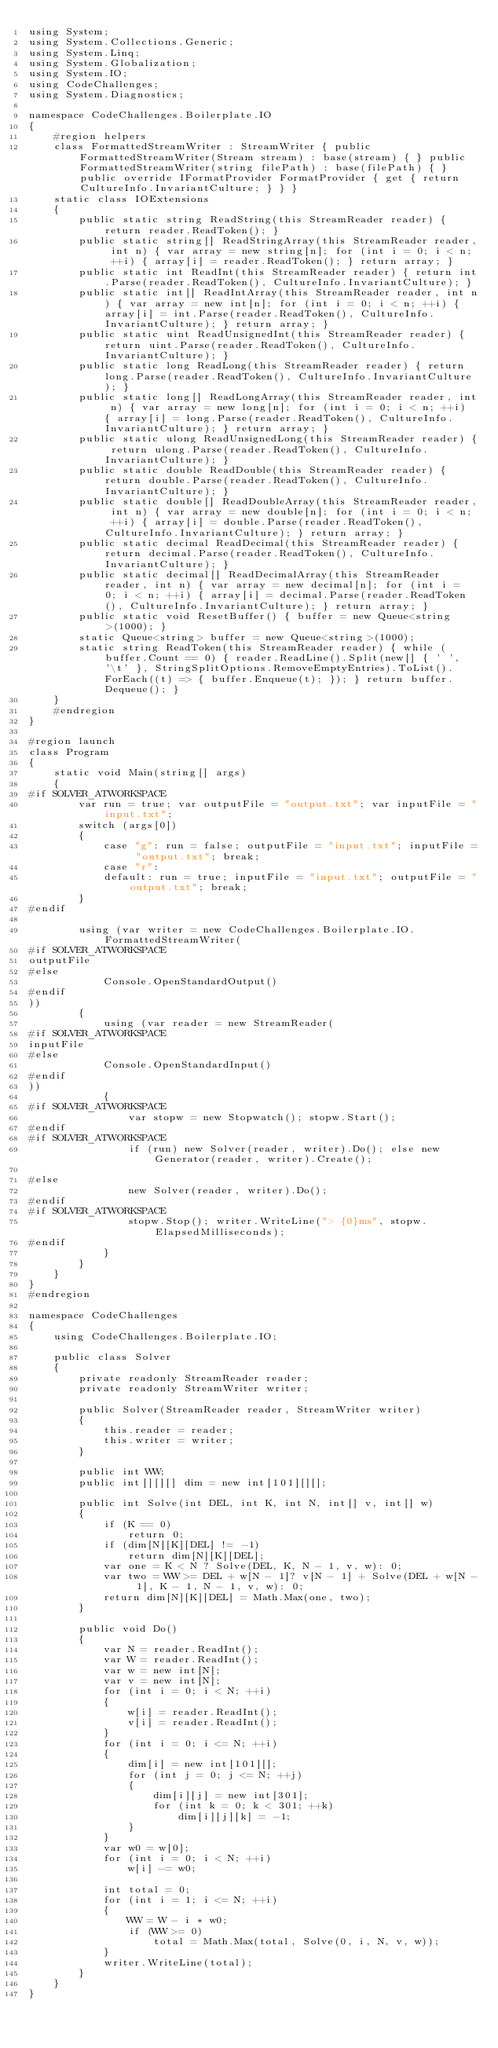Convert code to text. <code><loc_0><loc_0><loc_500><loc_500><_C#_>using System;
using System.Collections.Generic;
using System.Linq;
using System.Globalization;
using System.IO;
using CodeChallenges;
using System.Diagnostics;

namespace CodeChallenges.Boilerplate.IO
{
    #region helpers
    class FormattedStreamWriter : StreamWriter { public FormattedStreamWriter(Stream stream) : base(stream) { } public FormattedStreamWriter(string filePath) : base(filePath) { } public override IFormatProvider FormatProvider { get { return CultureInfo.InvariantCulture; } } }
    static class IOExtensions
    {
        public static string ReadString(this StreamReader reader) { return reader.ReadToken(); }
        public static string[] ReadStringArray(this StreamReader reader, int n) { var array = new string[n]; for (int i = 0; i < n; ++i) { array[i] = reader.ReadToken(); } return array; }
        public static int ReadInt(this StreamReader reader) { return int.Parse(reader.ReadToken(), CultureInfo.InvariantCulture); }
        public static int[] ReadIntArray(this StreamReader reader, int n) { var array = new int[n]; for (int i = 0; i < n; ++i) { array[i] = int.Parse(reader.ReadToken(), CultureInfo.InvariantCulture); } return array; }
        public static uint ReadUnsignedInt(this StreamReader reader) { return uint.Parse(reader.ReadToken(), CultureInfo.InvariantCulture); }
        public static long ReadLong(this StreamReader reader) { return long.Parse(reader.ReadToken(), CultureInfo.InvariantCulture); }
        public static long[] ReadLongArray(this StreamReader reader, int n) { var array = new long[n]; for (int i = 0; i < n; ++i) { array[i] = long.Parse(reader.ReadToken(), CultureInfo.InvariantCulture); } return array; }
        public static ulong ReadUnsignedLong(this StreamReader reader) { return ulong.Parse(reader.ReadToken(), CultureInfo.InvariantCulture); }
        public static double ReadDouble(this StreamReader reader) { return double.Parse(reader.ReadToken(), CultureInfo.InvariantCulture); }
        public static double[] ReadDoubleArray(this StreamReader reader, int n) { var array = new double[n]; for (int i = 0; i < n; ++i) { array[i] = double.Parse(reader.ReadToken(), CultureInfo.InvariantCulture); } return array; }
        public static decimal ReadDecimal(this StreamReader reader) { return decimal.Parse(reader.ReadToken(), CultureInfo.InvariantCulture); }
        public static decimal[] ReadDecimalArray(this StreamReader reader, int n) { var array = new decimal[n]; for (int i = 0; i < n; ++i) { array[i] = decimal.Parse(reader.ReadToken(), CultureInfo.InvariantCulture); } return array; }
        public static void ResetBuffer() { buffer = new Queue<string>(1000); }
        static Queue<string> buffer = new Queue<string>(1000);
        static string ReadToken(this StreamReader reader) { while (buffer.Count == 0) { reader.ReadLine().Split(new[] { ' ', '\t' }, StringSplitOptions.RemoveEmptyEntries).ToList().ForEach((t) => { buffer.Enqueue(t); }); } return buffer.Dequeue(); }
    }
    #endregion
}

#region launch
class Program
{
    static void Main(string[] args)
    {
#if SOLVER_ATWORKSPACE
        var run = true; var outputFile = "output.txt"; var inputFile = "input.txt";
        switch (args[0])
        {
            case "g": run = false; outputFile = "input.txt"; inputFile = "output.txt"; break;
            case "r":
            default: run = true; inputFile = "input.txt"; outputFile = "output.txt"; break;
        }
#endif

        using (var writer = new CodeChallenges.Boilerplate.IO.FormattedStreamWriter(
#if SOLVER_ATWORKSPACE
outputFile
#else
            Console.OpenStandardOutput()
#endif
))
        {
            using (var reader = new StreamReader(
#if SOLVER_ATWORKSPACE
inputFile
#else 
            Console.OpenStandardInput()
#endif
))
            {
#if SOLVER_ATWORKSPACE
                var stopw = new Stopwatch(); stopw.Start();
#endif
#if SOLVER_ATWORKSPACE
                if (run) new Solver(reader, writer).Do(); else new Generator(reader, writer).Create();

#else
                new Solver(reader, writer).Do();
#endif
#if SOLVER_ATWORKSPACE
                stopw.Stop(); writer.WriteLine("> {0}ms", stopw.ElapsedMilliseconds);
#endif
            }
        }
    }
}
#endregion

namespace CodeChallenges
{
    using CodeChallenges.Boilerplate.IO;

    public class Solver
    {
        private readonly StreamReader reader;
        private readonly StreamWriter writer;

        public Solver(StreamReader reader, StreamWriter writer)
        {
            this.reader = reader;
            this.writer = writer;
        }

        public int WW;
        public int[][][] dim = new int[101][][];

        public int Solve(int DEL, int K, int N, int[] v, int[] w)
        {
            if (K == 0)
                return 0;
            if (dim[N][K][DEL] != -1)
                return dim[N][K][DEL];
            var one = K < N ? Solve(DEL, K, N - 1, v, w): 0;
            var two = WW >= DEL + w[N - 1]? v[N - 1] + Solve(DEL + w[N - 1], K - 1, N - 1, v, w): 0;
            return dim[N][K][DEL] = Math.Max(one, two);
        }

        public void Do()
        {
            var N = reader.ReadInt();
            var W = reader.ReadInt();
            var w = new int[N];
            var v = new int[N];
            for (int i = 0; i < N; ++i)
            {
                w[i] = reader.ReadInt();
                v[i] = reader.ReadInt();
            }
            for (int i = 0; i <= N; ++i)
            {
                dim[i] = new int[101][];
                for (int j = 0; j <= N; ++j)
                {
                    dim[i][j] = new int[301];
                    for (int k = 0; k < 301; ++k)
                        dim[i][j][k] = -1;
                }
            }
            var w0 = w[0];
            for (int i = 0; i < N; ++i)
                w[i] -= w0;

            int total = 0;
            for (int i = 1; i <= N; ++i)
            {
                WW = W - i * w0;
                if (WW >= 0)
                    total = Math.Max(total, Solve(0, i, N, v, w));
            }
            writer.WriteLine(total);
        }
    }
}</code> 